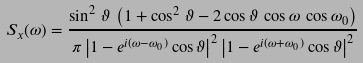Convert formula to latex. <formula><loc_0><loc_0><loc_500><loc_500>S _ { x } ( \omega ) = \frac { \sin ^ { 2 } \, \vartheta \, \left ( 1 + \cos ^ { 2 } \, \vartheta - 2 \cos \vartheta \, \cos \omega \, \cos \omega _ { 0 } \right ) } { \pi \left | 1 - e ^ { i ( \omega - \omega _ { 0 } ) } \cos \vartheta \right | ^ { 2 } \left | 1 - e ^ { i ( \omega + \omega _ { 0 } ) } \cos \vartheta \right | ^ { 2 } }</formula> 